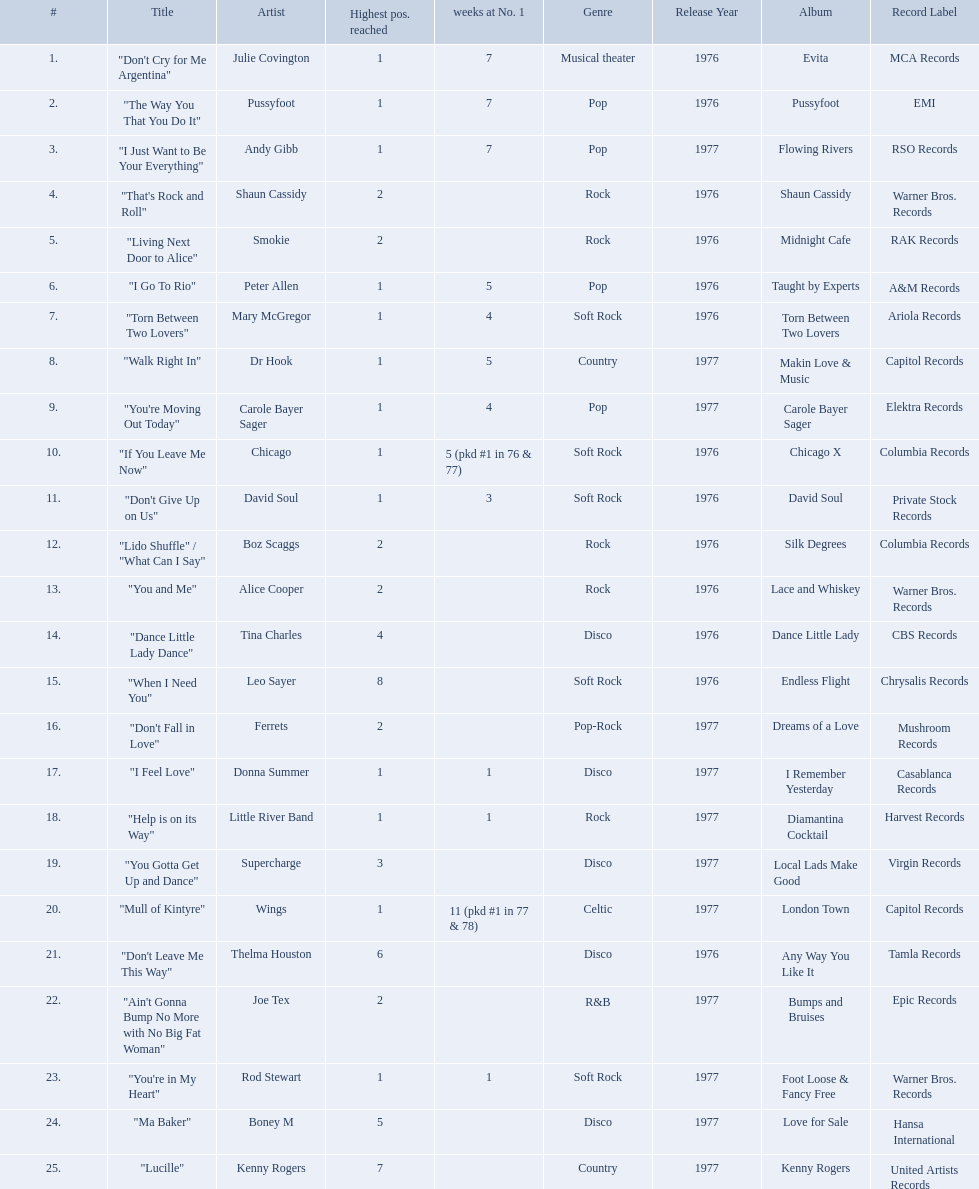Which artists were included in the top 25 singles for 1977 in australia? Julie Covington, Pussyfoot, Andy Gibb, Shaun Cassidy, Smokie, Peter Allen, Mary McGregor, Dr Hook, Carole Bayer Sager, Chicago, David Soul, Boz Scaggs, Alice Cooper, Tina Charles, Leo Sayer, Ferrets, Donna Summer, Little River Band, Supercharge, Wings, Thelma Houston, Joe Tex, Rod Stewart, Boney M, Kenny Rogers. And for how many weeks did they chart at number 1? 7, 7, 7, , , 5, 4, 5, 4, 5 (pkd #1 in 76 & 77), 3, , , , , , 1, 1, , 11 (pkd #1 in 77 & 78), , , 1, , . Which artist was in the number 1 spot for most time? Wings. 